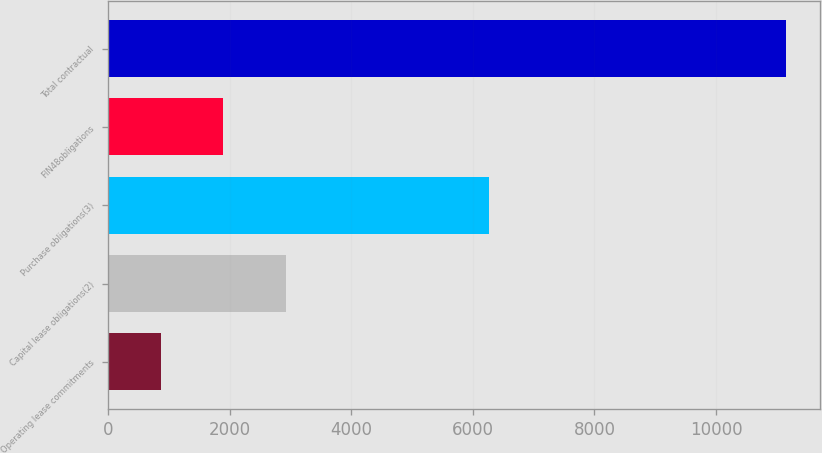<chart> <loc_0><loc_0><loc_500><loc_500><bar_chart><fcel>Operating lease commitments<fcel>Capital lease obligations(2)<fcel>Purchase obligations(3)<fcel>FIN48obligations<fcel>Total contractual<nl><fcel>868<fcel>2925.6<fcel>6259<fcel>1896.8<fcel>11156<nl></chart> 